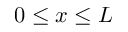<formula> <loc_0><loc_0><loc_500><loc_500>0 \leq x \leq L</formula> 